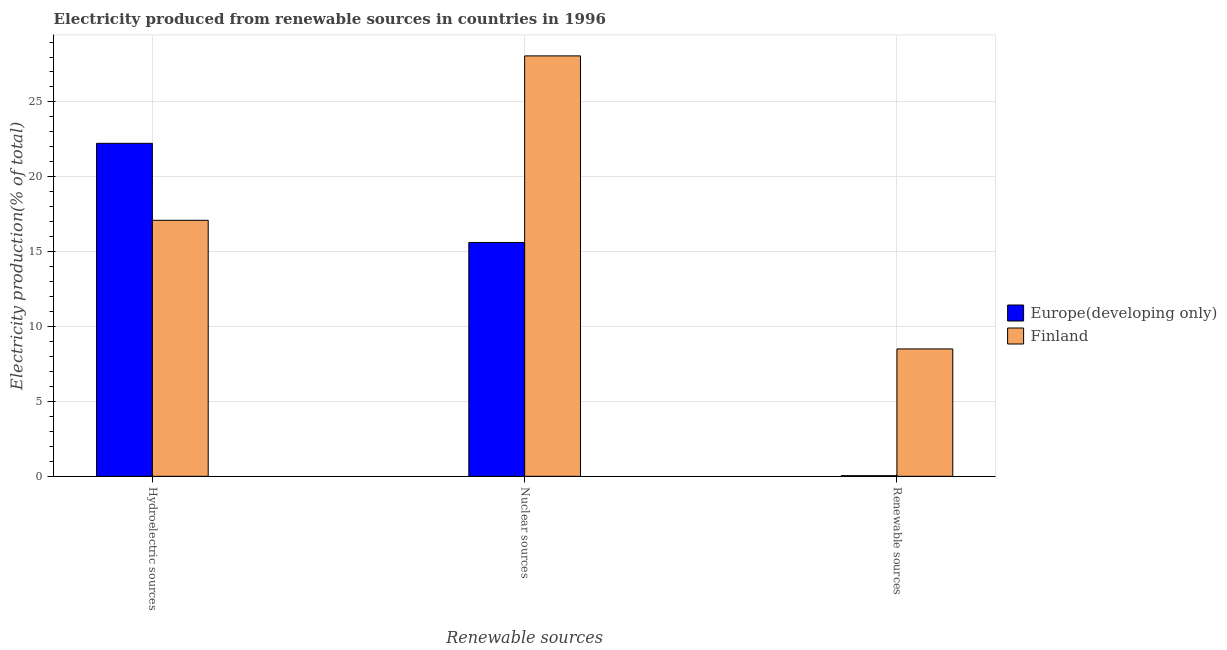Are the number of bars per tick equal to the number of legend labels?
Your response must be concise. Yes. Are the number of bars on each tick of the X-axis equal?
Provide a succinct answer. Yes. How many bars are there on the 3rd tick from the left?
Ensure brevity in your answer.  2. How many bars are there on the 3rd tick from the right?
Provide a short and direct response. 2. What is the label of the 3rd group of bars from the left?
Offer a very short reply. Renewable sources. What is the percentage of electricity produced by renewable sources in Finland?
Your answer should be very brief. 8.51. Across all countries, what is the maximum percentage of electricity produced by nuclear sources?
Your response must be concise. 28.07. Across all countries, what is the minimum percentage of electricity produced by renewable sources?
Provide a short and direct response. 0.04. In which country was the percentage of electricity produced by renewable sources maximum?
Make the answer very short. Finland. What is the total percentage of electricity produced by renewable sources in the graph?
Provide a succinct answer. 8.55. What is the difference between the percentage of electricity produced by hydroelectric sources in Europe(developing only) and that in Finland?
Keep it short and to the point. 5.14. What is the difference between the percentage of electricity produced by hydroelectric sources in Europe(developing only) and the percentage of electricity produced by nuclear sources in Finland?
Offer a very short reply. -5.84. What is the average percentage of electricity produced by renewable sources per country?
Provide a short and direct response. 4.27. What is the difference between the percentage of electricity produced by renewable sources and percentage of electricity produced by hydroelectric sources in Europe(developing only)?
Make the answer very short. -22.2. In how many countries, is the percentage of electricity produced by hydroelectric sources greater than 17 %?
Make the answer very short. 2. What is the ratio of the percentage of electricity produced by hydroelectric sources in Europe(developing only) to that in Finland?
Give a very brief answer. 1.3. What is the difference between the highest and the second highest percentage of electricity produced by renewable sources?
Ensure brevity in your answer.  8.47. What is the difference between the highest and the lowest percentage of electricity produced by renewable sources?
Your answer should be very brief. 8.47. In how many countries, is the percentage of electricity produced by nuclear sources greater than the average percentage of electricity produced by nuclear sources taken over all countries?
Provide a short and direct response. 1. Is the sum of the percentage of electricity produced by renewable sources in Finland and Europe(developing only) greater than the maximum percentage of electricity produced by hydroelectric sources across all countries?
Give a very brief answer. No. What does the 1st bar from the left in Renewable sources represents?
Offer a terse response. Europe(developing only). What does the 2nd bar from the right in Renewable sources represents?
Your answer should be very brief. Europe(developing only). What is the difference between two consecutive major ticks on the Y-axis?
Your answer should be very brief. 5. Does the graph contain any zero values?
Your answer should be very brief. No. Where does the legend appear in the graph?
Give a very brief answer. Center right. How many legend labels are there?
Ensure brevity in your answer.  2. What is the title of the graph?
Provide a short and direct response. Electricity produced from renewable sources in countries in 1996. Does "United Arab Emirates" appear as one of the legend labels in the graph?
Keep it short and to the point. No. What is the label or title of the X-axis?
Make the answer very short. Renewable sources. What is the Electricity production(% of total) in Europe(developing only) in Hydroelectric sources?
Your answer should be compact. 22.24. What is the Electricity production(% of total) of Finland in Hydroelectric sources?
Offer a terse response. 17.1. What is the Electricity production(% of total) of Europe(developing only) in Nuclear sources?
Your response must be concise. 15.61. What is the Electricity production(% of total) in Finland in Nuclear sources?
Make the answer very short. 28.07. What is the Electricity production(% of total) in Europe(developing only) in Renewable sources?
Your answer should be compact. 0.04. What is the Electricity production(% of total) in Finland in Renewable sources?
Offer a very short reply. 8.51. Across all Renewable sources, what is the maximum Electricity production(% of total) in Europe(developing only)?
Your answer should be very brief. 22.24. Across all Renewable sources, what is the maximum Electricity production(% of total) in Finland?
Offer a very short reply. 28.07. Across all Renewable sources, what is the minimum Electricity production(% of total) of Europe(developing only)?
Your response must be concise. 0.04. Across all Renewable sources, what is the minimum Electricity production(% of total) in Finland?
Your answer should be very brief. 8.51. What is the total Electricity production(% of total) of Europe(developing only) in the graph?
Ensure brevity in your answer.  37.89. What is the total Electricity production(% of total) of Finland in the graph?
Your answer should be very brief. 53.68. What is the difference between the Electricity production(% of total) in Europe(developing only) in Hydroelectric sources and that in Nuclear sources?
Your answer should be very brief. 6.62. What is the difference between the Electricity production(% of total) of Finland in Hydroelectric sources and that in Nuclear sources?
Ensure brevity in your answer.  -10.98. What is the difference between the Electricity production(% of total) in Europe(developing only) in Hydroelectric sources and that in Renewable sources?
Your answer should be very brief. 22.2. What is the difference between the Electricity production(% of total) in Finland in Hydroelectric sources and that in Renewable sources?
Give a very brief answer. 8.59. What is the difference between the Electricity production(% of total) in Europe(developing only) in Nuclear sources and that in Renewable sources?
Offer a very short reply. 15.57. What is the difference between the Electricity production(% of total) in Finland in Nuclear sources and that in Renewable sources?
Your answer should be compact. 19.57. What is the difference between the Electricity production(% of total) in Europe(developing only) in Hydroelectric sources and the Electricity production(% of total) in Finland in Nuclear sources?
Offer a very short reply. -5.84. What is the difference between the Electricity production(% of total) in Europe(developing only) in Hydroelectric sources and the Electricity production(% of total) in Finland in Renewable sources?
Your answer should be compact. 13.73. What is the difference between the Electricity production(% of total) in Europe(developing only) in Nuclear sources and the Electricity production(% of total) in Finland in Renewable sources?
Your response must be concise. 7.11. What is the average Electricity production(% of total) in Europe(developing only) per Renewable sources?
Make the answer very short. 12.63. What is the average Electricity production(% of total) in Finland per Renewable sources?
Keep it short and to the point. 17.89. What is the difference between the Electricity production(% of total) of Europe(developing only) and Electricity production(% of total) of Finland in Hydroelectric sources?
Provide a succinct answer. 5.14. What is the difference between the Electricity production(% of total) in Europe(developing only) and Electricity production(% of total) in Finland in Nuclear sources?
Provide a short and direct response. -12.46. What is the difference between the Electricity production(% of total) in Europe(developing only) and Electricity production(% of total) in Finland in Renewable sources?
Keep it short and to the point. -8.47. What is the ratio of the Electricity production(% of total) of Europe(developing only) in Hydroelectric sources to that in Nuclear sources?
Offer a terse response. 1.42. What is the ratio of the Electricity production(% of total) in Finland in Hydroelectric sources to that in Nuclear sources?
Ensure brevity in your answer.  0.61. What is the ratio of the Electricity production(% of total) in Europe(developing only) in Hydroelectric sources to that in Renewable sources?
Give a very brief answer. 555.22. What is the ratio of the Electricity production(% of total) in Finland in Hydroelectric sources to that in Renewable sources?
Provide a succinct answer. 2.01. What is the ratio of the Electricity production(% of total) in Europe(developing only) in Nuclear sources to that in Renewable sources?
Your answer should be very brief. 389.88. What is the ratio of the Electricity production(% of total) of Finland in Nuclear sources to that in Renewable sources?
Ensure brevity in your answer.  3.3. What is the difference between the highest and the second highest Electricity production(% of total) of Europe(developing only)?
Offer a terse response. 6.62. What is the difference between the highest and the second highest Electricity production(% of total) of Finland?
Your answer should be very brief. 10.98. What is the difference between the highest and the lowest Electricity production(% of total) of Europe(developing only)?
Your answer should be compact. 22.2. What is the difference between the highest and the lowest Electricity production(% of total) in Finland?
Ensure brevity in your answer.  19.57. 